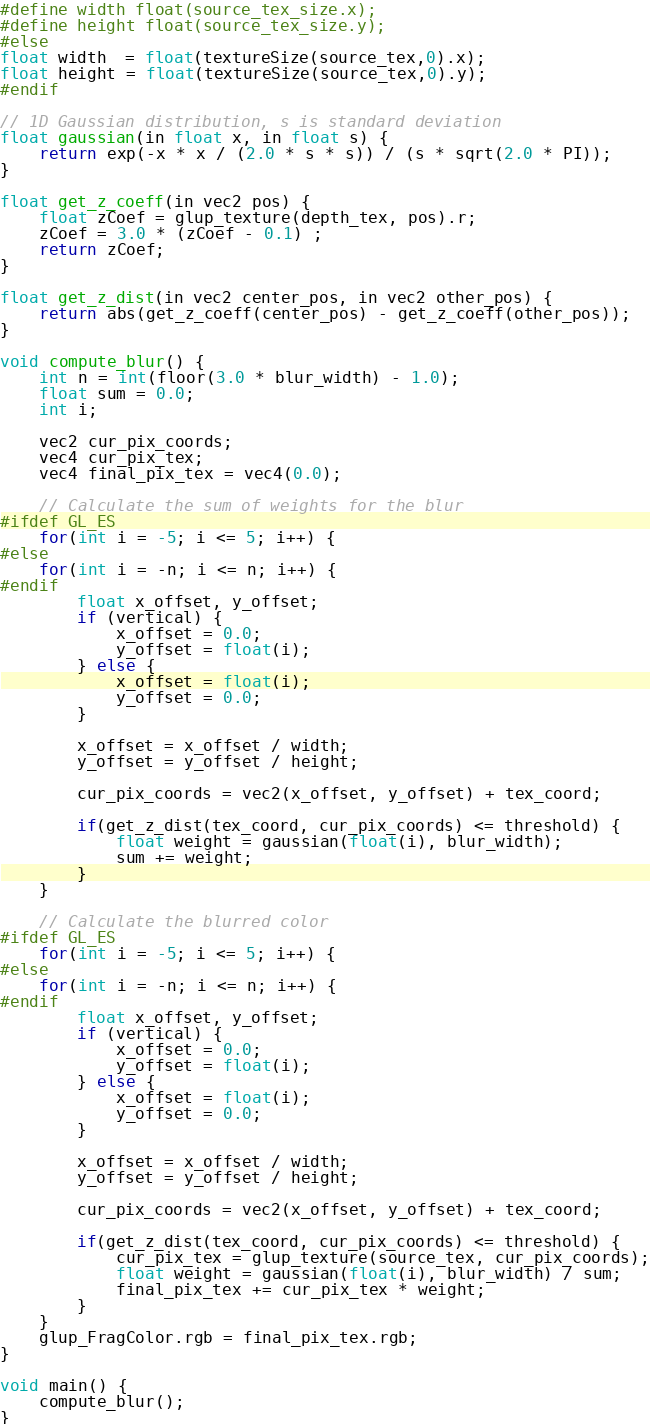Convert code to text. <code><loc_0><loc_0><loc_500><loc_500><_C_>#define width float(source_tex_size.x);
#define height float(source_tex_size.y);
#else
float width  = float(textureSize(source_tex,0).x);
float height = float(textureSize(source_tex,0).y);
#endif

// 1D Gaussian distribution, s is standard deviation
float gaussian(in float x, in float s) {
    return exp(-x * x / (2.0 * s * s)) / (s * sqrt(2.0 * PI));
}

float get_z_coeff(in vec2 pos) {
    float zCoef = glup_texture(depth_tex, pos).r;
    zCoef = 3.0 * (zCoef - 0.1) ;
    return zCoef;
}

float get_z_dist(in vec2 center_pos, in vec2 other_pos) {
    return abs(get_z_coeff(center_pos) - get_z_coeff(other_pos));
}

void compute_blur() {
    int n = int(floor(3.0 * blur_width) - 1.0);
    float sum = 0.0;
    int i;
    
    vec2 cur_pix_coords;
    vec4 cur_pix_tex;
    vec4 final_pix_tex = vec4(0.0);
    
    // Calculate the sum of weights for the blur
#ifdef GL_ES
    for(int i = -5; i <= 5; i++) {    
#else    
    for(int i = -n; i <= n; i++) {
#endif	
        float x_offset, y_offset;
        if (vertical) {
            x_offset = 0.0;
            y_offset = float(i);
        } else {
            x_offset = float(i);
            y_offset = 0.0;
        }
        
        x_offset = x_offset / width;
        y_offset = y_offset / height;
        
        cur_pix_coords = vec2(x_offset, y_offset) + tex_coord;
        
        if(get_z_dist(tex_coord, cur_pix_coords) <= threshold) {
            float weight = gaussian(float(i), blur_width);
            sum += weight;
        }
    }
    
    // Calculate the blurred color
#ifdef GL_ES
    for(int i = -5; i <= 5; i++) {    
#else    
    for(int i = -n; i <= n; i++) {
#endif	
        float x_offset, y_offset;
        if (vertical) {
            x_offset = 0.0;
            y_offset = float(i);
        } else {
            x_offset = float(i);
            y_offset = 0.0;
        }
        
        x_offset = x_offset / width;
        y_offset = y_offset / height;
        
        cur_pix_coords = vec2(x_offset, y_offset) + tex_coord;
        
        if(get_z_dist(tex_coord, cur_pix_coords) <= threshold) {
            cur_pix_tex = glup_texture(source_tex, cur_pix_coords);
            float weight = gaussian(float(i), blur_width) / sum;
            final_pix_tex += cur_pix_tex * weight;
        }
    }
    glup_FragColor.rgb = final_pix_tex.rgb;
}

void main() {
    compute_blur();
}

</code> 